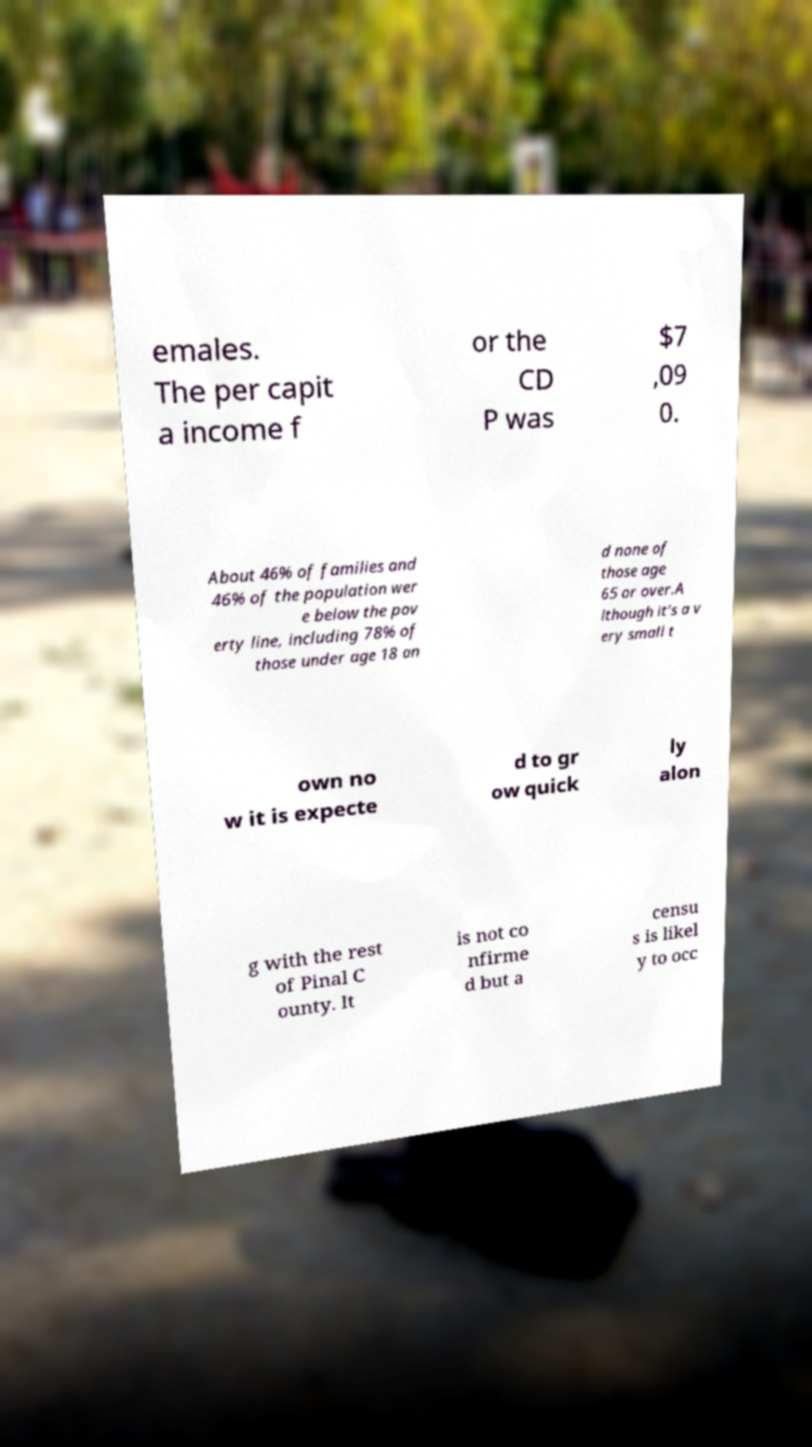Can you accurately transcribe the text from the provided image for me? emales. The per capit a income f or the CD P was $7 ,09 0. About 46% of families and 46% of the population wer e below the pov erty line, including 78% of those under age 18 an d none of those age 65 or over.A lthough it's a v ery small t own no w it is expecte d to gr ow quick ly alon g with the rest of Pinal C ounty. It is not co nfirme d but a censu s is likel y to occ 